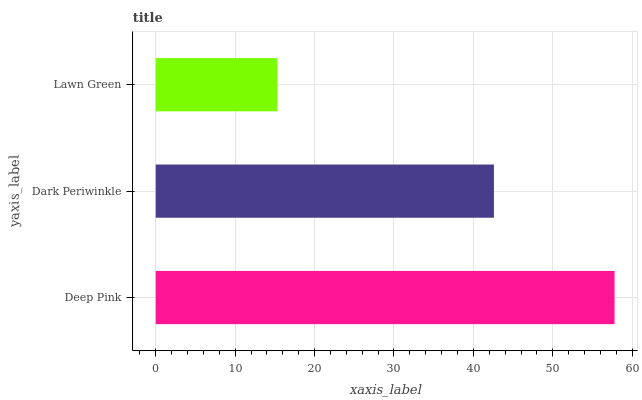Is Lawn Green the minimum?
Answer yes or no. Yes. Is Deep Pink the maximum?
Answer yes or no. Yes. Is Dark Periwinkle the minimum?
Answer yes or no. No. Is Dark Periwinkle the maximum?
Answer yes or no. No. Is Deep Pink greater than Dark Periwinkle?
Answer yes or no. Yes. Is Dark Periwinkle less than Deep Pink?
Answer yes or no. Yes. Is Dark Periwinkle greater than Deep Pink?
Answer yes or no. No. Is Deep Pink less than Dark Periwinkle?
Answer yes or no. No. Is Dark Periwinkle the high median?
Answer yes or no. Yes. Is Dark Periwinkle the low median?
Answer yes or no. Yes. Is Lawn Green the high median?
Answer yes or no. No. Is Deep Pink the low median?
Answer yes or no. No. 